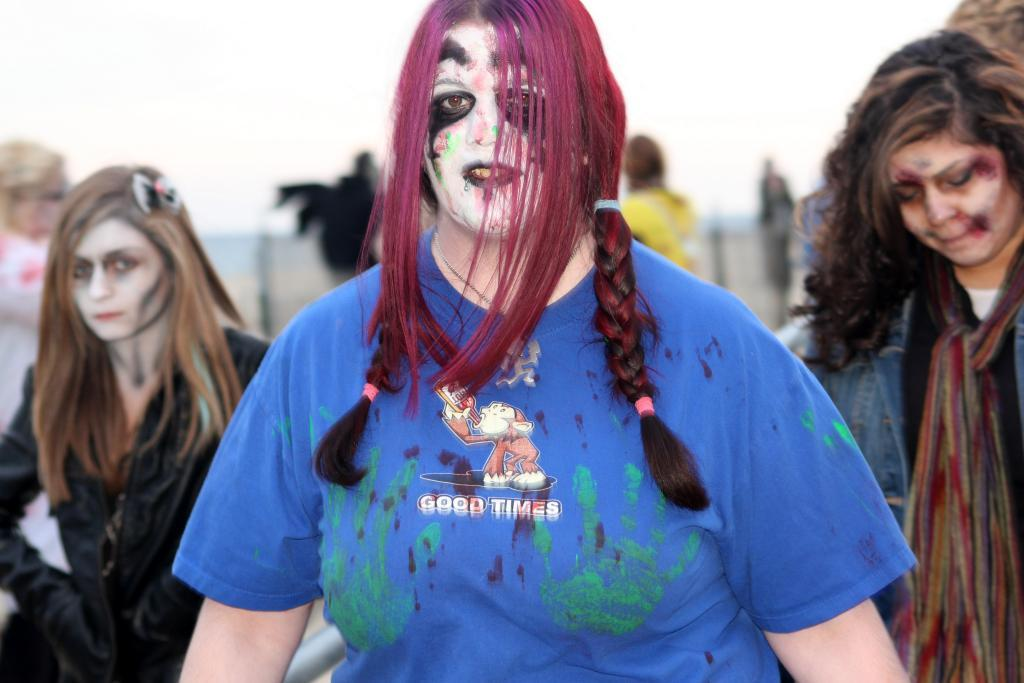How many women are present in the image? There are three women in the image. Where are the women located in the image? The women are standing on the road. What can be seen in the background of the image? There is a blurred image in the background. What is visible at the top of the image? The sky is visible at the top of the image. What type of game are the women playing in the image? There is no game being played in the image; the women are simply standing on the road. How many cars can be seen passing by in the image? There are no cars visible in the image; it only shows the three women standing on the road. 